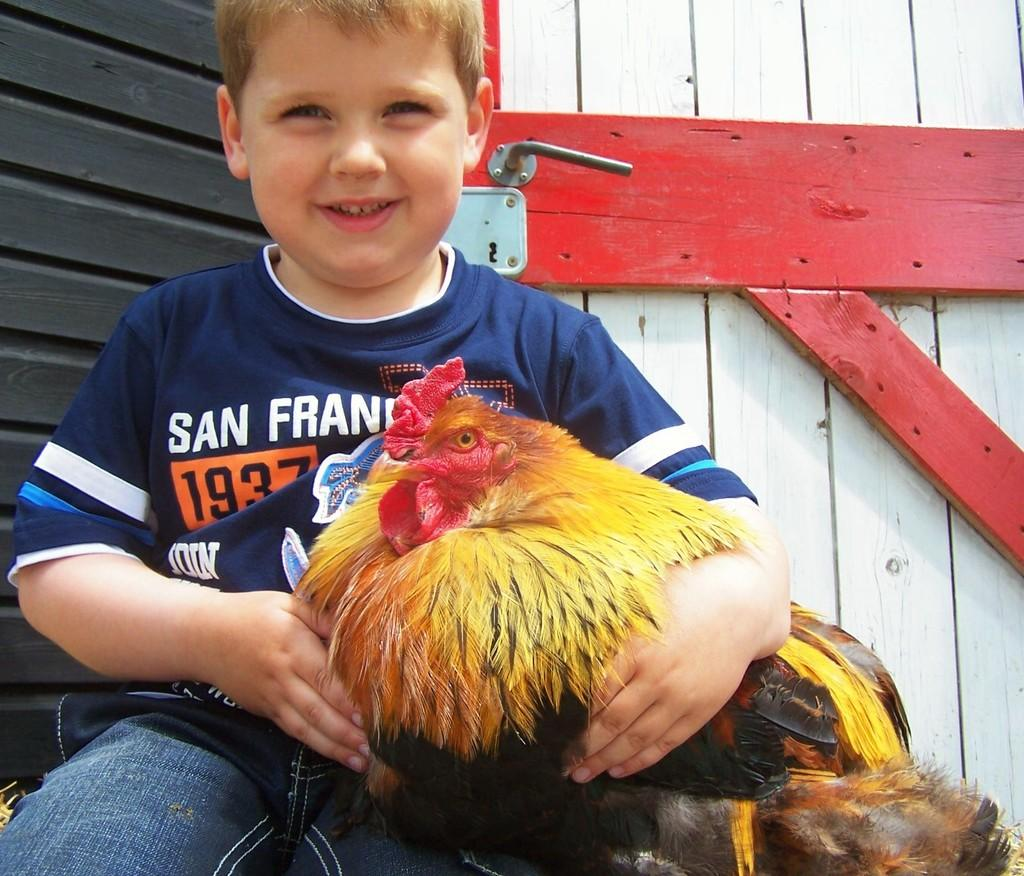Who is the main subject in the image? There is a boy in the image. What is the boy holding in the image? The boy is holding a hen. What can be seen in the background of the image? There are doors visible in the background of the image. What type of spoon can be seen in the alley next to the prison in the image? There is no spoon, alley, or prison present in the image. 